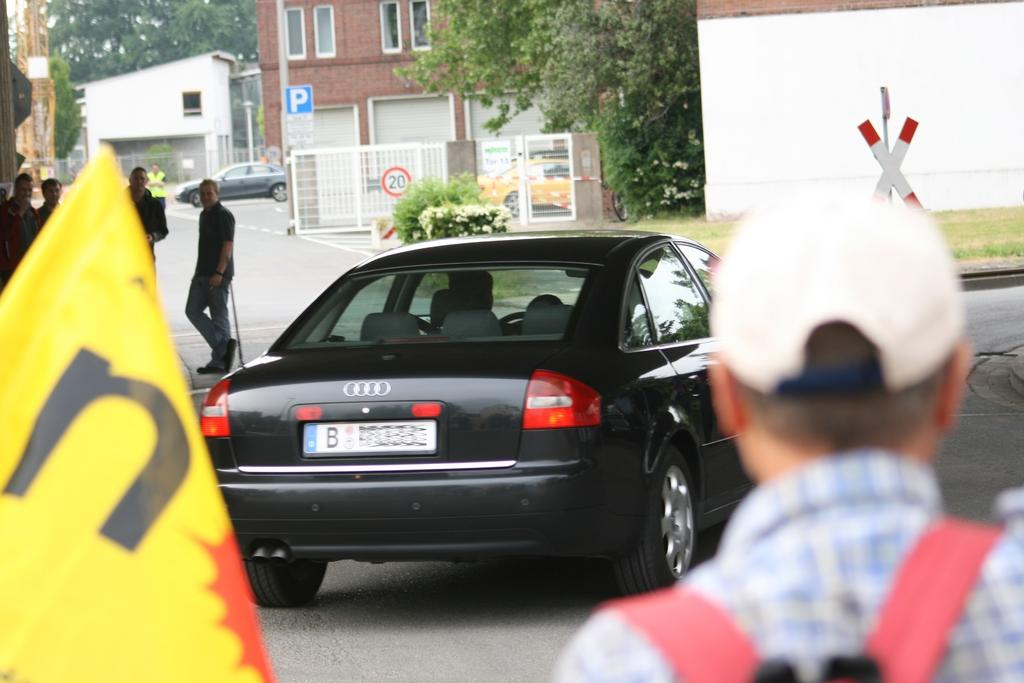Provide a one-sentence caption for the provided image. A black Audi with a license plate that starts with B is parked in a shady area. 